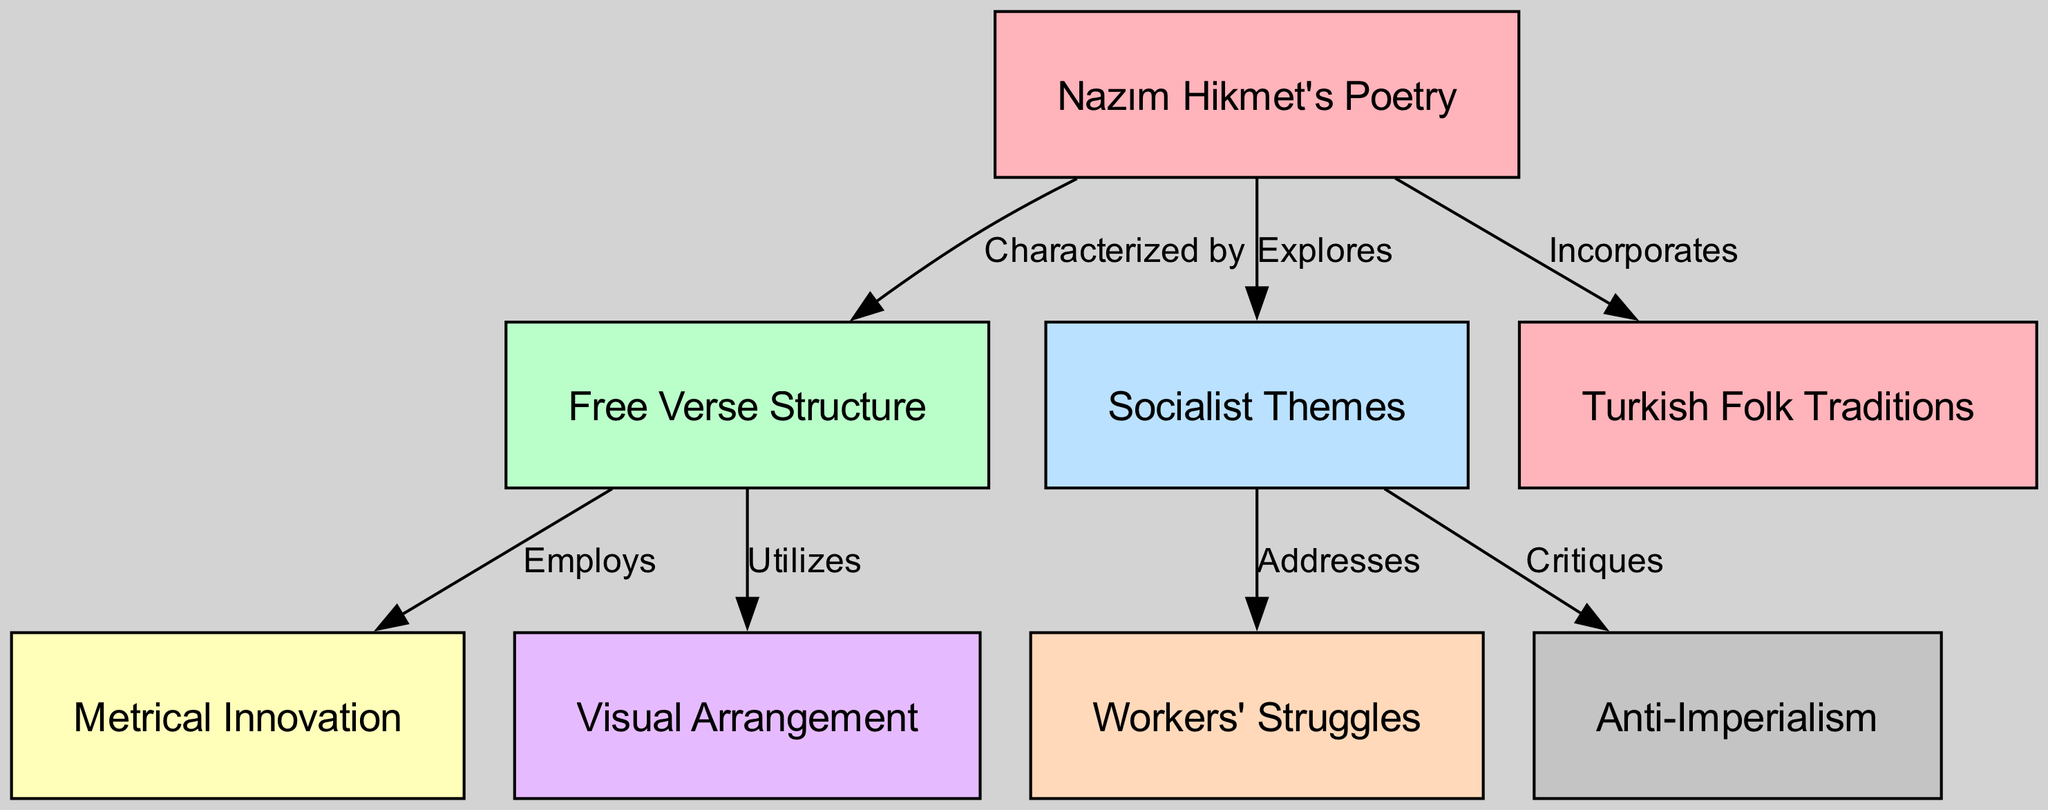What is the main structure of Nazım Hikmet's poetry? The diagram identifies "Free Verse Structure" as the main characteristic of Nazım Hikmet's poetry, which is central in the analysis presented.
Answer: Free Verse Structure How many themes related to socialism are addressed in Nazım Hikmet's poetry? The diagram shows two distinct socialist themes, "Workers' Struggles" and "Anti-Imperialism," that are explored in his work, indicating the thematic depth.
Answer: Two Which element does Nazım Hikmet's poetry specifically utilize in its free verse structure? The diagram connects "Free Verse Structure" with "Metrical Innovation," indicating the unique techniques employed in his poetry.
Answer: Metrical Innovation What traditional influences are incorporated into Nazım Hikmet's poetry? According to the diagram, "Turkish Folk Traditions" are specifically incorporated into his poetic works, showcasing the blend of contemporary and traditional elements.
Answer: Turkish Folk Traditions What does Nazım Hikmet's poetry critique in relation to socialism? The diagram illustrates that his poetry critiques "Imperialism" as part of its exploration of socialist themes, signaling a critical engagement with broader socio-political issues.
Answer: Anti-Imperialism Which relationship exists between Nazım Hikmet's poetry and visual arrangement? The diagram shows that Nazım Hikmet's poetry "Utilizes" visual arrangement as an element in its free verse structure, indicating the importance of layout in conveying meaning.
Answer: Utilizes What societal issues are predominantly addressed in Nazım Hikmet's poetry? The diagram confirms that his poetry addresses "Workers' Struggles," reflecting the socio-economic concerns relevant to his political ideology and literary focus.
Answer: Workers' Struggles How many nodes are present in the diagram? There are eight nodes identified in the diagram, each representing a unique aspect of Nazım Hikmet's poetry and its structural analysis.
Answer: Eight What type of thematic exploration is emphasized in Nazım Hikmet's poetry? The diagram makes clear that "Socialist Themes" are a fundamental focus of Hikmet's work, emphasizing the socio-political context of his poetry.
Answer: Socialist Themes 